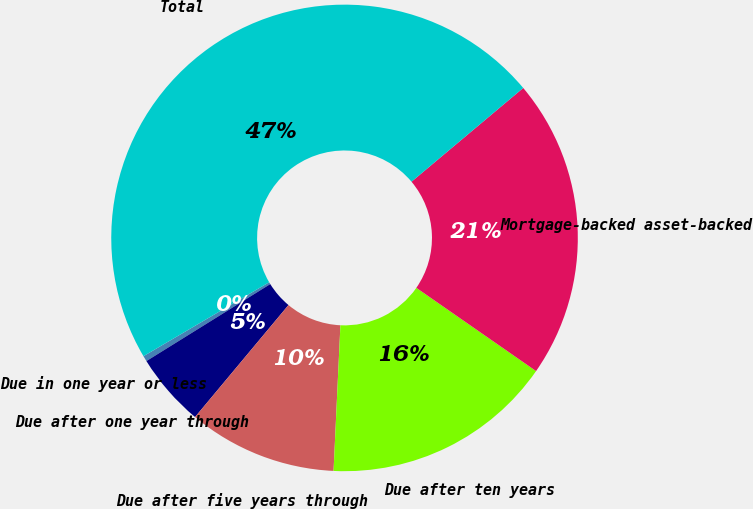Convert chart. <chart><loc_0><loc_0><loc_500><loc_500><pie_chart><fcel>Due in one year or less<fcel>Due after one year through<fcel>Due after five years through<fcel>Due after ten years<fcel>Mortgage-backed asset-backed<fcel>Total<nl><fcel>0.39%<fcel>5.08%<fcel>10.32%<fcel>16.08%<fcel>20.78%<fcel>47.35%<nl></chart> 